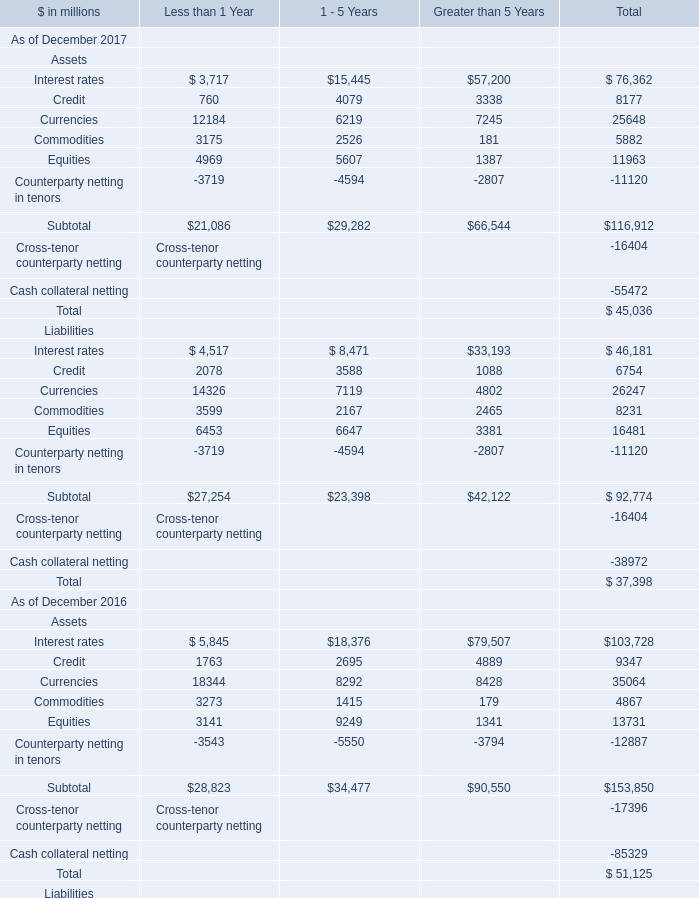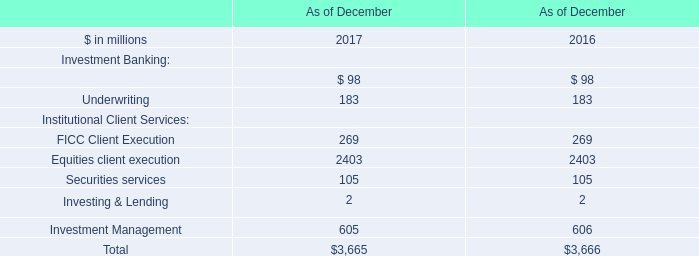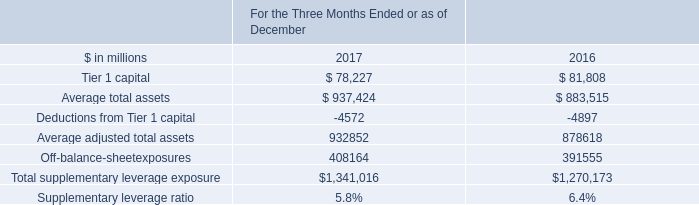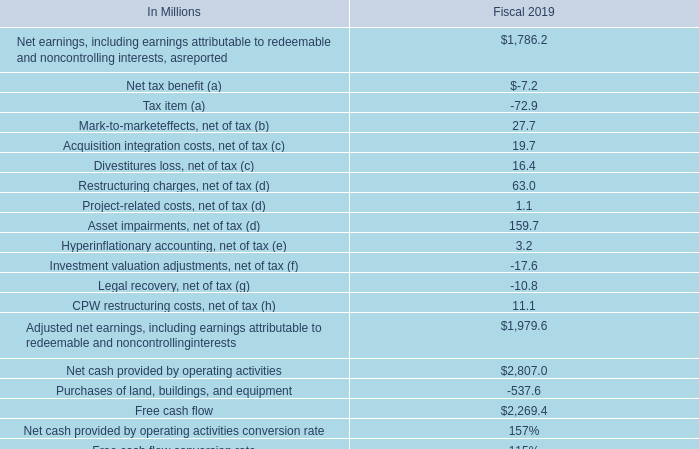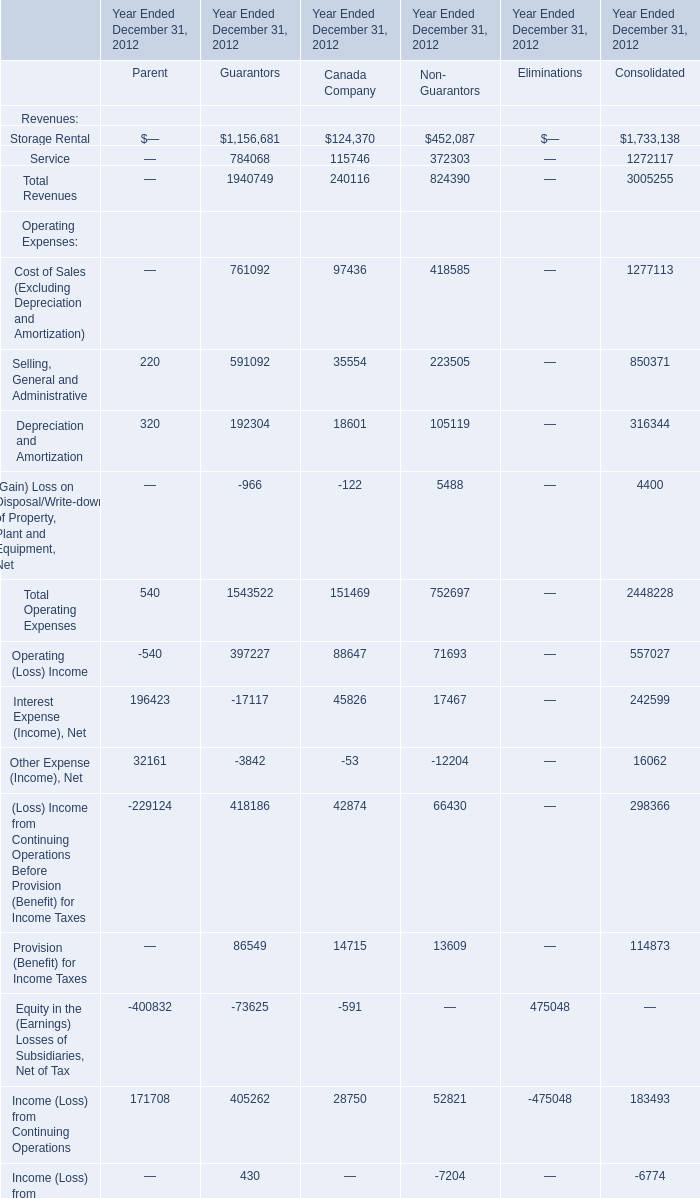What is the sum of the (Loss) Income from Continuing Operations Before Provision (Benefit) for Income Taxes in the year where Selling, General and Administrative greater than 0? 
Computations: (((-229124 + 418186) + 42874) + 66430)
Answer: 298366.0. 